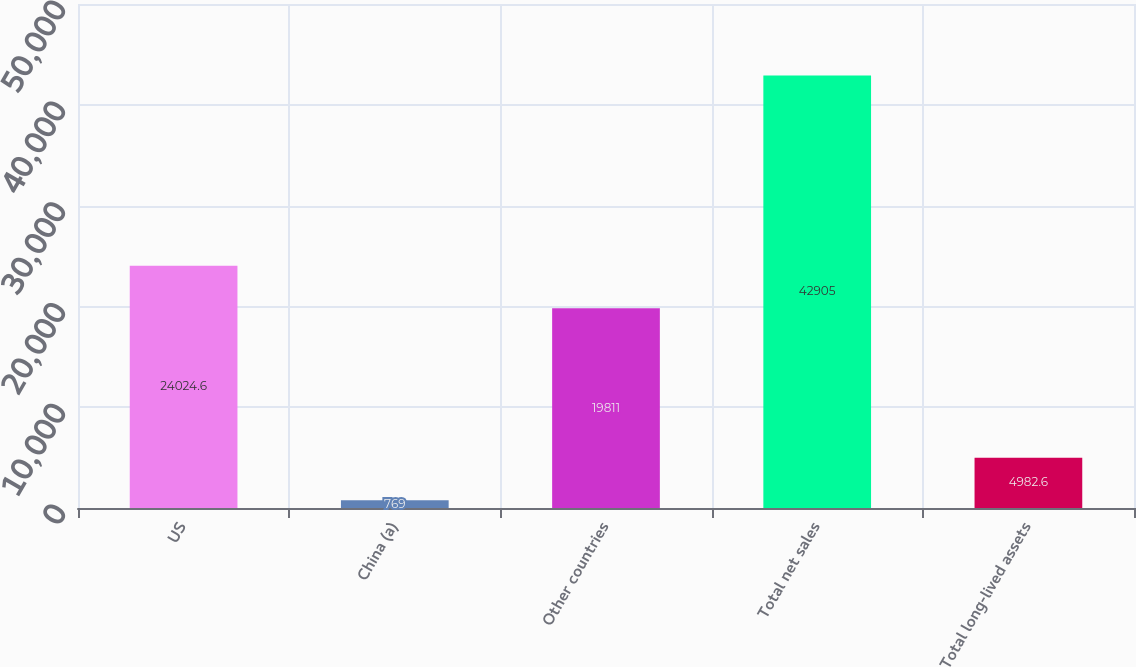Convert chart to OTSL. <chart><loc_0><loc_0><loc_500><loc_500><bar_chart><fcel>US<fcel>China (a)<fcel>Other countries<fcel>Total net sales<fcel>Total long-lived assets<nl><fcel>24024.6<fcel>769<fcel>19811<fcel>42905<fcel>4982.6<nl></chart> 